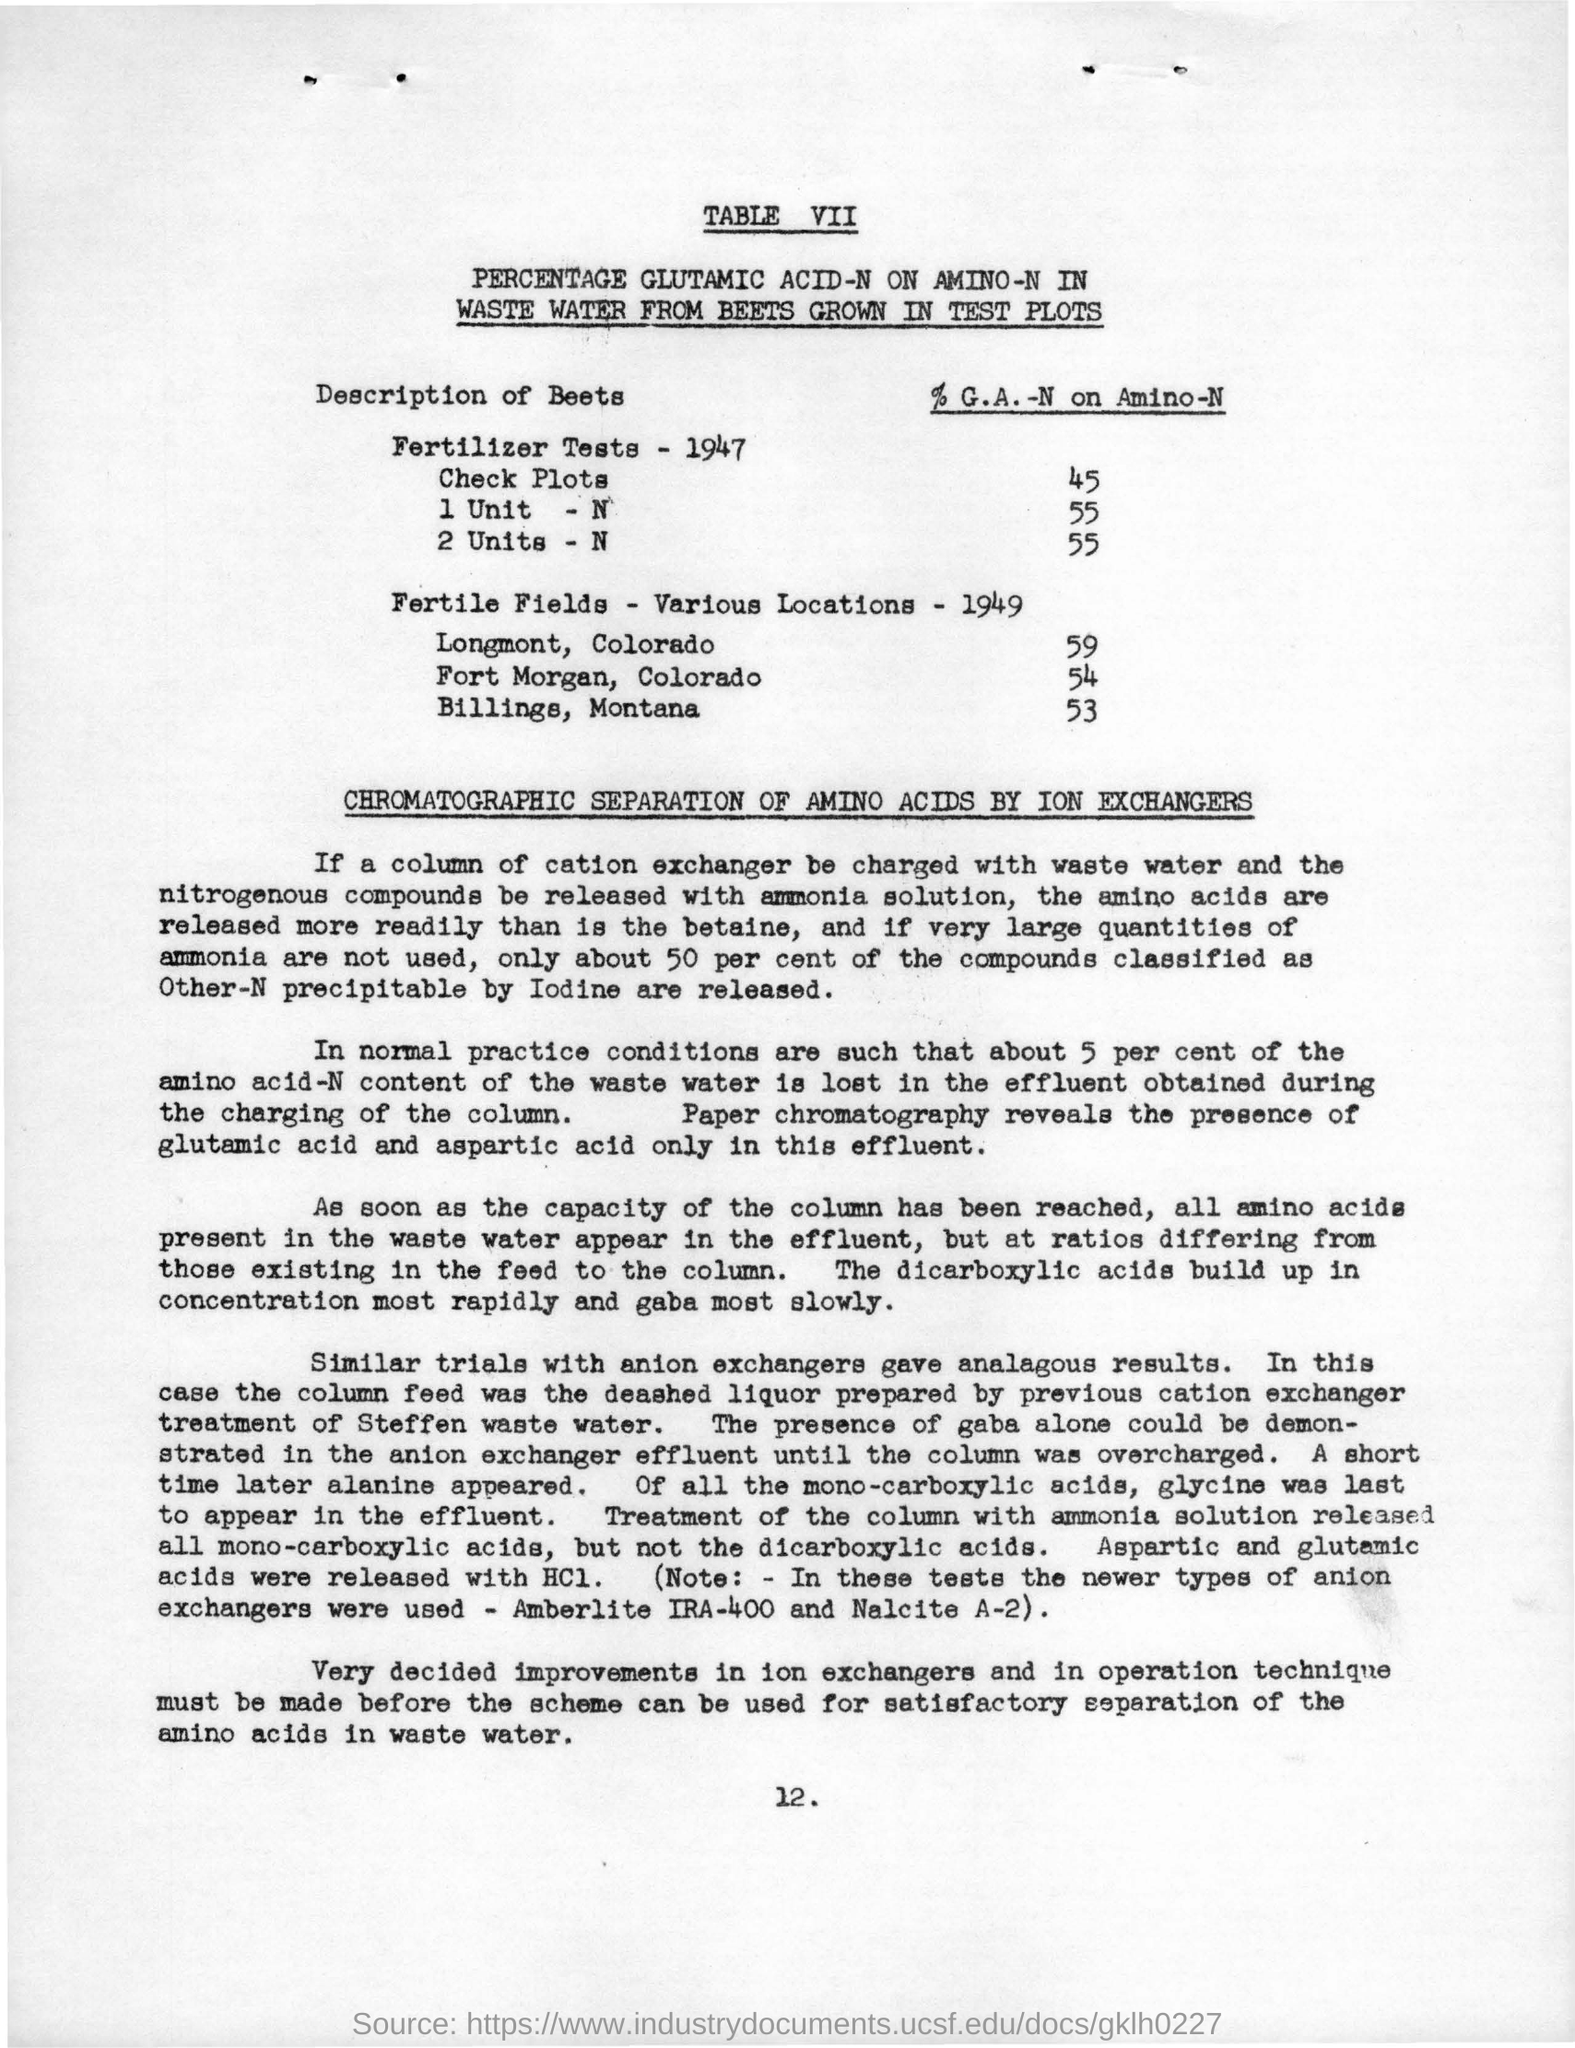Outline some significant characteristics in this image. There are 53 fertile fields located in Billings, Montana. There are 54 fertile fields located in Fort Morgan, Colorado. Chromatographic separation of amino acids is achieved through the use of ion exchangers. There are currently 59 fertile fields located in Longmont, Colorado. 